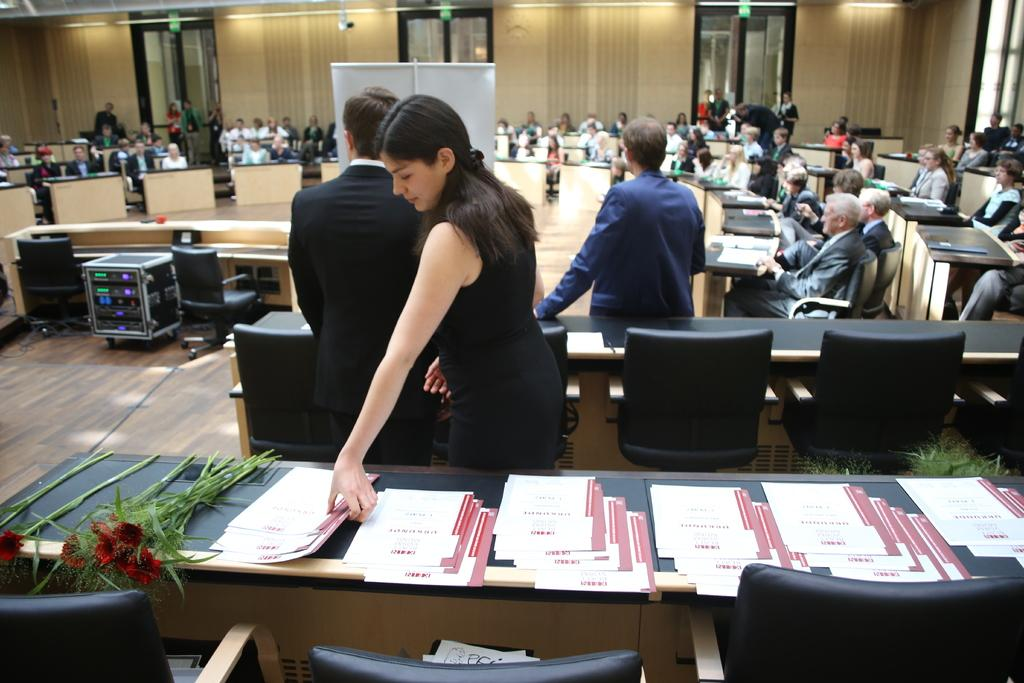What is present on the table in the image? There are papers and flowers on the table in the image. What are the people doing in the image? There is a group of people sitting inside a hall. Is there anyone holding papers in the image? Yes, one person is holding papers. What type of oil is being used to fuel the cars in the image? There are no cars present in the image, so it is not possible to determine what type of oil is being used to fuel them. What language are the people speaking in the image? The image does not provide any information about the language being spoken by the people. 